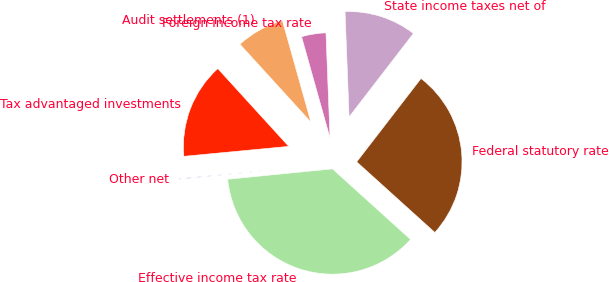Convert chart. <chart><loc_0><loc_0><loc_500><loc_500><pie_chart><fcel>Federal statutory rate<fcel>State income taxes net of<fcel>Foreign income tax rate<fcel>Audit settlements (1)<fcel>Tax advantaged investments<fcel>Other net<fcel>Effective income tax rate<nl><fcel>26.24%<fcel>11.07%<fcel>3.74%<fcel>7.41%<fcel>14.74%<fcel>0.07%<fcel>36.73%<nl></chart> 